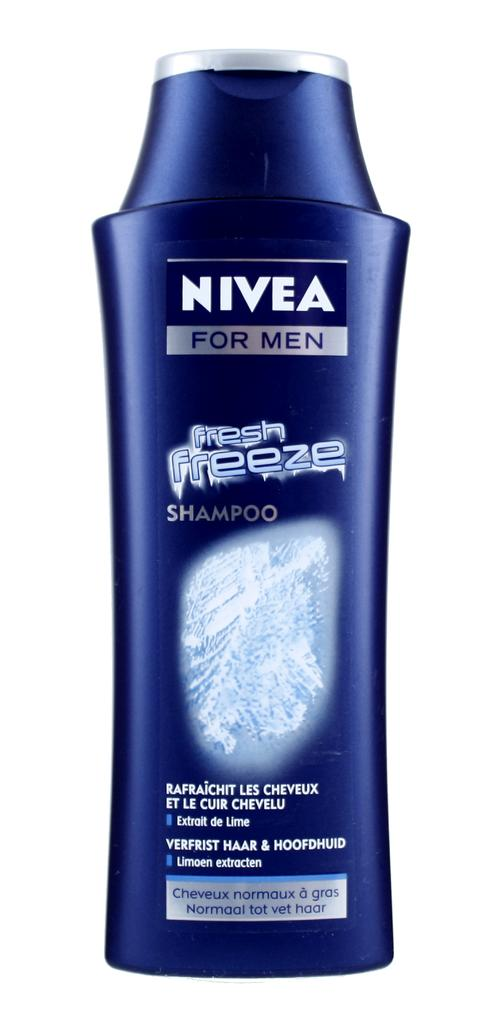<image>
Give a short and clear explanation of the subsequent image. a shampoo bottle with the word nivea on it 